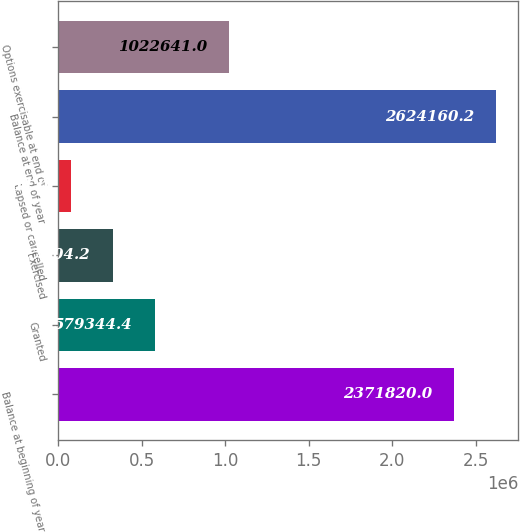Convert chart to OTSL. <chart><loc_0><loc_0><loc_500><loc_500><bar_chart><fcel>Balance at beginning of year<fcel>Granted<fcel>Exercised<fcel>Lapsed or cancelled<fcel>Balance at end of year<fcel>Options exercisable at end of<nl><fcel>2.37182e+06<fcel>579344<fcel>327004<fcel>74664<fcel>2.62416e+06<fcel>1.02264e+06<nl></chart> 